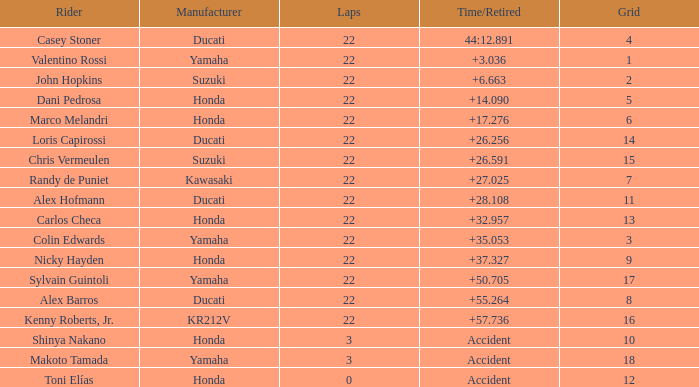What is the average grid for competitors who had more than 22 laps and time/retired of +17.276? None. 